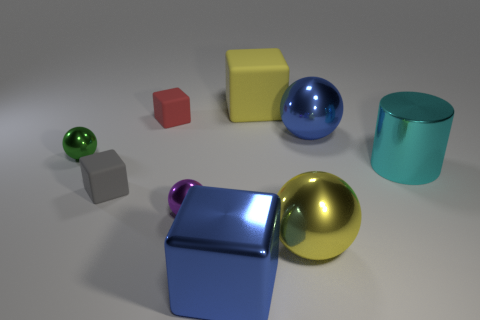What is the shape of the big blue thing on the right side of the big shiny cube? sphere 